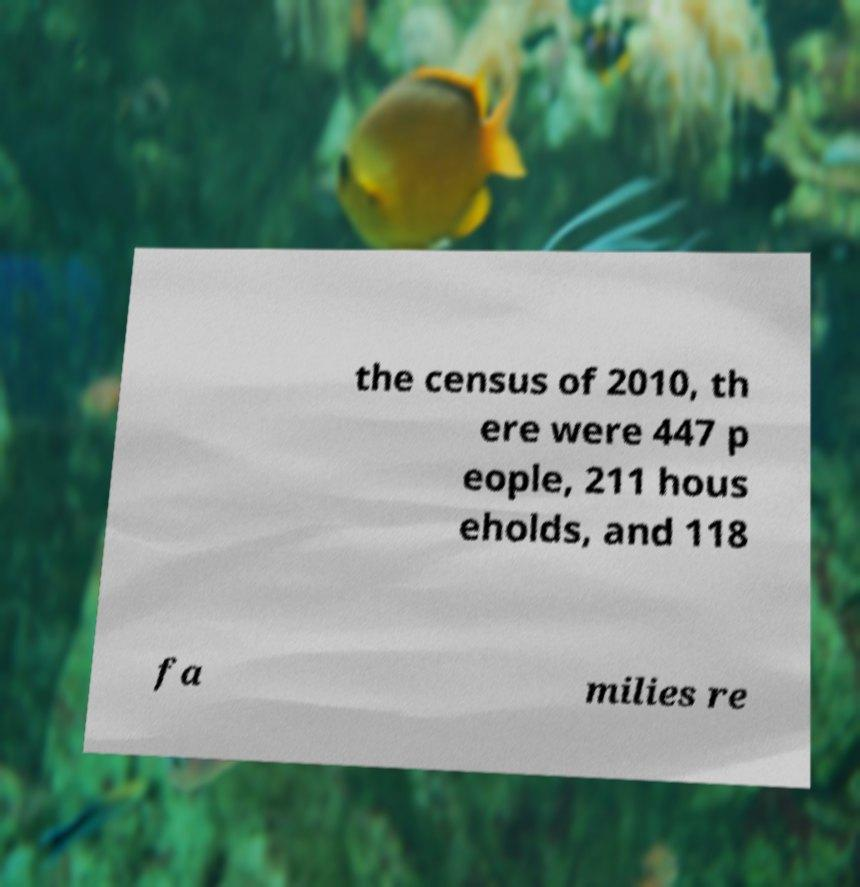Please identify and transcribe the text found in this image. the census of 2010, th ere were 447 p eople, 211 hous eholds, and 118 fa milies re 